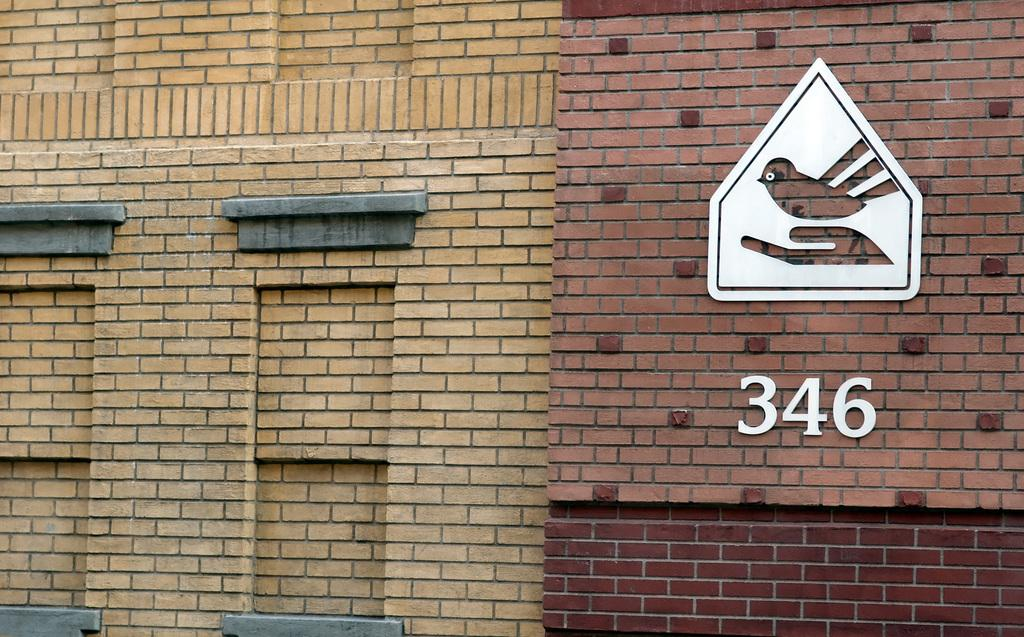What type of structures are visible in the image? There are walls of buildings in the image. Can you describe any specific features on the walls? Yes, there is a frame on one of the walls. What is depicted inside the frame? The frame contains a structure of a bird. Is there any text or numbers visible on the walls? Yes, the number "346" is written on the wall. What type of sugar is used to sweeten the stew in the image? There is no sugar or stew present in the image; it features walls of buildings with a frame containing a bird structure and the number "346" written on the wall. 